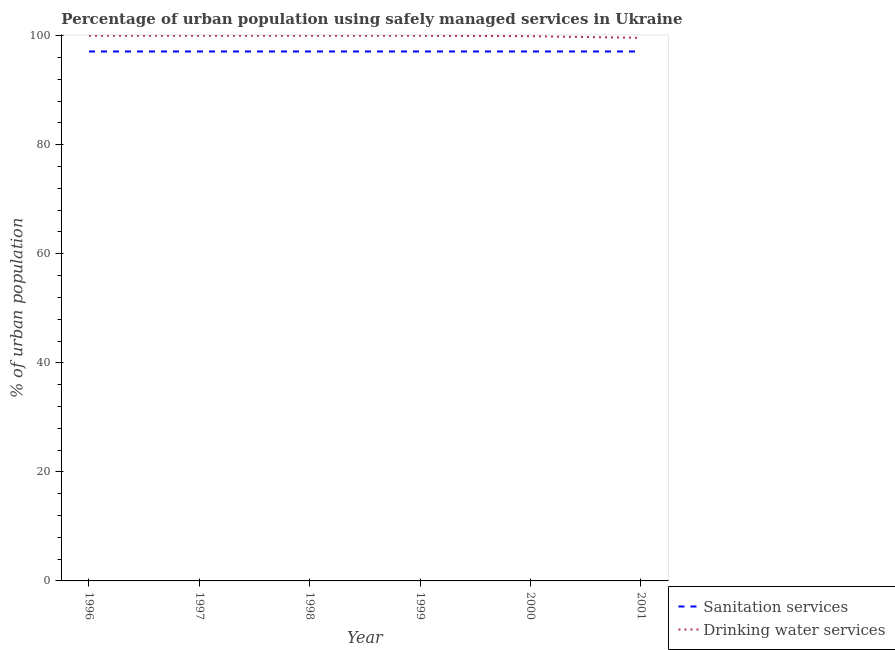Does the line corresponding to percentage of urban population who used sanitation services intersect with the line corresponding to percentage of urban population who used drinking water services?
Your answer should be compact. No. Is the number of lines equal to the number of legend labels?
Offer a very short reply. Yes. What is the percentage of urban population who used sanitation services in 1998?
Your response must be concise. 97.1. Across all years, what is the minimum percentage of urban population who used sanitation services?
Your answer should be very brief. 97.1. In which year was the percentage of urban population who used drinking water services minimum?
Make the answer very short. 2001. What is the total percentage of urban population who used sanitation services in the graph?
Your answer should be compact. 582.6. What is the average percentage of urban population who used drinking water services per year?
Offer a terse response. 99.92. In the year 1997, what is the difference between the percentage of urban population who used drinking water services and percentage of urban population who used sanitation services?
Make the answer very short. 2.9. Is the percentage of urban population who used sanitation services in 1996 less than that in 2000?
Your response must be concise. No. Is the difference between the percentage of urban population who used drinking water services in 1996 and 1999 greater than the difference between the percentage of urban population who used sanitation services in 1996 and 1999?
Your answer should be compact. No. Is the percentage of urban population who used drinking water services strictly less than the percentage of urban population who used sanitation services over the years?
Offer a very short reply. No. How many years are there in the graph?
Offer a very short reply. 6. Does the graph contain any zero values?
Keep it short and to the point. No. Does the graph contain grids?
Give a very brief answer. No. What is the title of the graph?
Offer a very short reply. Percentage of urban population using safely managed services in Ukraine. What is the label or title of the X-axis?
Provide a short and direct response. Year. What is the label or title of the Y-axis?
Keep it short and to the point. % of urban population. What is the % of urban population in Sanitation services in 1996?
Keep it short and to the point. 97.1. What is the % of urban population in Drinking water services in 1996?
Make the answer very short. 100. What is the % of urban population in Sanitation services in 1997?
Give a very brief answer. 97.1. What is the % of urban population in Drinking water services in 1997?
Offer a terse response. 100. What is the % of urban population in Sanitation services in 1998?
Offer a very short reply. 97.1. What is the % of urban population in Sanitation services in 1999?
Offer a terse response. 97.1. What is the % of urban population of Drinking water services in 1999?
Your answer should be compact. 100. What is the % of urban population of Sanitation services in 2000?
Keep it short and to the point. 97.1. What is the % of urban population in Drinking water services in 2000?
Your answer should be very brief. 99.9. What is the % of urban population in Sanitation services in 2001?
Make the answer very short. 97.1. What is the % of urban population of Drinking water services in 2001?
Offer a terse response. 99.6. Across all years, what is the maximum % of urban population of Sanitation services?
Make the answer very short. 97.1. Across all years, what is the minimum % of urban population in Sanitation services?
Ensure brevity in your answer.  97.1. Across all years, what is the minimum % of urban population in Drinking water services?
Your answer should be compact. 99.6. What is the total % of urban population of Sanitation services in the graph?
Keep it short and to the point. 582.6. What is the total % of urban population in Drinking water services in the graph?
Offer a terse response. 599.5. What is the difference between the % of urban population in Sanitation services in 1996 and that in 1997?
Keep it short and to the point. 0. What is the difference between the % of urban population in Drinking water services in 1996 and that in 1997?
Offer a terse response. 0. What is the difference between the % of urban population of Sanitation services in 1996 and that in 1999?
Your answer should be compact. 0. What is the difference between the % of urban population of Sanitation services in 1996 and that in 2001?
Your answer should be very brief. 0. What is the difference between the % of urban population of Drinking water services in 1997 and that in 1998?
Ensure brevity in your answer.  0. What is the difference between the % of urban population in Sanitation services in 1997 and that in 1999?
Ensure brevity in your answer.  0. What is the difference between the % of urban population in Drinking water services in 1997 and that in 2001?
Provide a succinct answer. 0.4. What is the difference between the % of urban population in Drinking water services in 1998 and that in 1999?
Provide a succinct answer. 0. What is the difference between the % of urban population in Sanitation services in 1998 and that in 2000?
Ensure brevity in your answer.  0. What is the difference between the % of urban population in Drinking water services in 1998 and that in 2000?
Ensure brevity in your answer.  0.1. What is the difference between the % of urban population of Sanitation services in 1998 and that in 2001?
Your answer should be compact. 0. What is the difference between the % of urban population of Sanitation services in 1999 and that in 2000?
Offer a terse response. 0. What is the difference between the % of urban population in Sanitation services in 1999 and that in 2001?
Make the answer very short. 0. What is the difference between the % of urban population in Sanitation services in 2000 and that in 2001?
Offer a terse response. 0. What is the difference between the % of urban population in Sanitation services in 1996 and the % of urban population in Drinking water services in 1997?
Make the answer very short. -2.9. What is the difference between the % of urban population in Sanitation services in 1996 and the % of urban population in Drinking water services in 2000?
Ensure brevity in your answer.  -2.8. What is the difference between the % of urban population of Sanitation services in 1997 and the % of urban population of Drinking water services in 1998?
Offer a very short reply. -2.9. What is the difference between the % of urban population in Sanitation services in 1997 and the % of urban population in Drinking water services in 2000?
Your answer should be compact. -2.8. What is the difference between the % of urban population in Sanitation services in 1998 and the % of urban population in Drinking water services in 2000?
Ensure brevity in your answer.  -2.8. What is the difference between the % of urban population in Sanitation services in 1999 and the % of urban population in Drinking water services in 2000?
Ensure brevity in your answer.  -2.8. What is the difference between the % of urban population of Sanitation services in 1999 and the % of urban population of Drinking water services in 2001?
Keep it short and to the point. -2.5. What is the difference between the % of urban population in Sanitation services in 2000 and the % of urban population in Drinking water services in 2001?
Make the answer very short. -2.5. What is the average % of urban population of Sanitation services per year?
Ensure brevity in your answer.  97.1. What is the average % of urban population of Drinking water services per year?
Give a very brief answer. 99.92. In the year 1997, what is the difference between the % of urban population in Sanitation services and % of urban population in Drinking water services?
Make the answer very short. -2.9. In the year 2000, what is the difference between the % of urban population of Sanitation services and % of urban population of Drinking water services?
Offer a terse response. -2.8. What is the ratio of the % of urban population in Sanitation services in 1996 to that in 1998?
Keep it short and to the point. 1. What is the ratio of the % of urban population in Drinking water services in 1996 to that in 1998?
Your answer should be compact. 1. What is the ratio of the % of urban population in Drinking water services in 1996 to that in 2000?
Ensure brevity in your answer.  1. What is the ratio of the % of urban population in Drinking water services in 1996 to that in 2001?
Make the answer very short. 1. What is the ratio of the % of urban population of Sanitation services in 1997 to that in 1998?
Ensure brevity in your answer.  1. What is the ratio of the % of urban population of Sanitation services in 1997 to that in 1999?
Ensure brevity in your answer.  1. What is the ratio of the % of urban population of Sanitation services in 1997 to that in 2000?
Provide a succinct answer. 1. What is the ratio of the % of urban population of Drinking water services in 1997 to that in 2000?
Your answer should be very brief. 1. What is the ratio of the % of urban population of Drinking water services in 1997 to that in 2001?
Your answer should be very brief. 1. What is the ratio of the % of urban population in Sanitation services in 1998 to that in 1999?
Offer a very short reply. 1. What is the ratio of the % of urban population in Drinking water services in 1998 to that in 1999?
Your response must be concise. 1. What is the ratio of the % of urban population of Drinking water services in 1998 to that in 2000?
Offer a very short reply. 1. What is the ratio of the % of urban population in Sanitation services in 1998 to that in 2001?
Your response must be concise. 1. What is the ratio of the % of urban population in Sanitation services in 1999 to that in 2000?
Provide a succinct answer. 1. What is the ratio of the % of urban population of Drinking water services in 1999 to that in 2000?
Make the answer very short. 1. What is the ratio of the % of urban population in Sanitation services in 1999 to that in 2001?
Your answer should be very brief. 1. What is the ratio of the % of urban population of Sanitation services in 2000 to that in 2001?
Make the answer very short. 1. What is the difference between the highest and the second highest % of urban population in Sanitation services?
Give a very brief answer. 0. What is the difference between the highest and the second highest % of urban population in Drinking water services?
Your answer should be compact. 0. What is the difference between the highest and the lowest % of urban population in Sanitation services?
Offer a terse response. 0. 